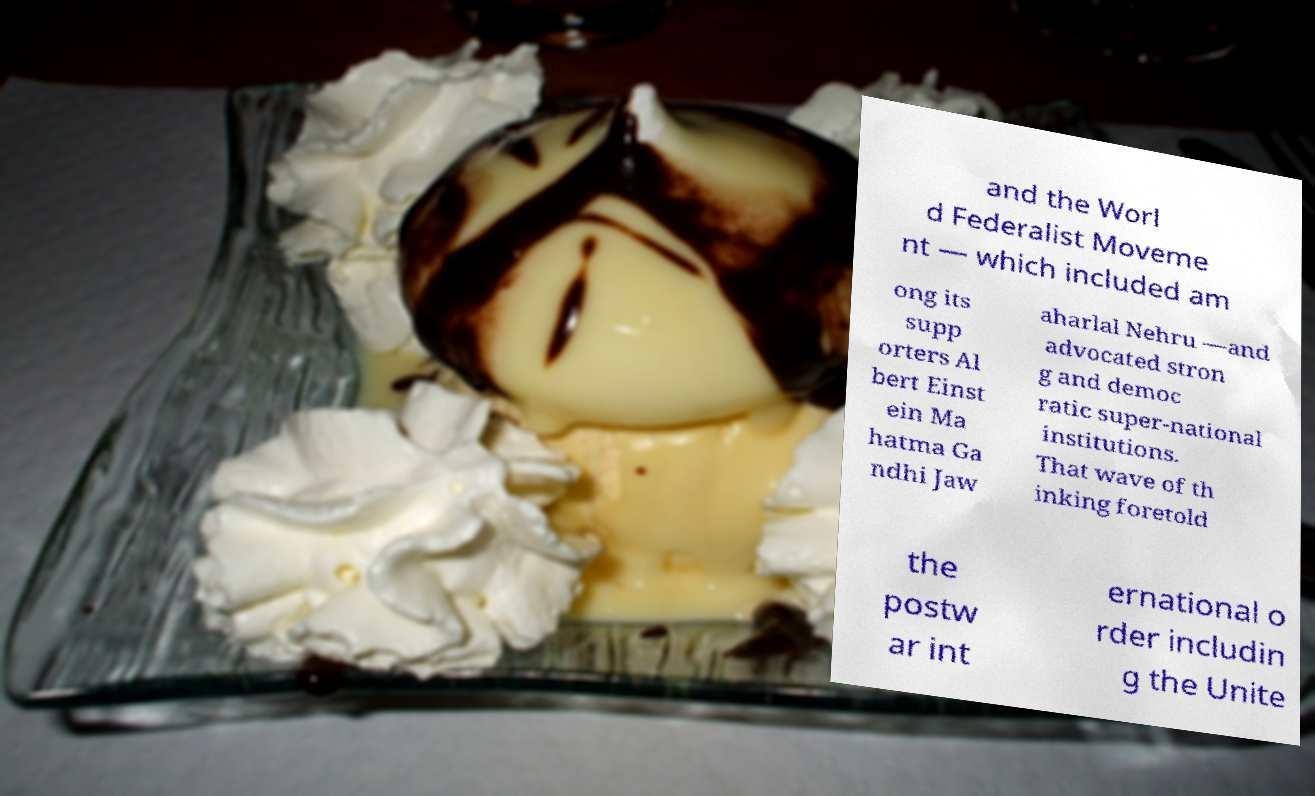There's text embedded in this image that I need extracted. Can you transcribe it verbatim? and the Worl d Federalist Moveme nt — which included am ong its supp orters Al bert Einst ein Ma hatma Ga ndhi Jaw aharlal Nehru —and advocated stron g and democ ratic super-national institutions. That wave of th inking foretold the postw ar int ernational o rder includin g the Unite 